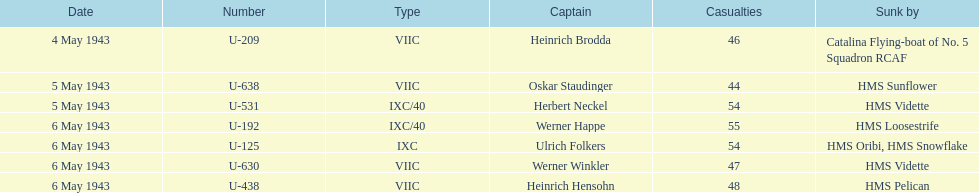How many additional casualties took place on may 6 in comparison to may 4? 158. 